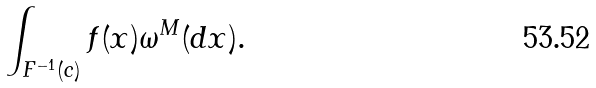Convert formula to latex. <formula><loc_0><loc_0><loc_500><loc_500>\int _ { F ^ { - 1 } ( c ) } f ( x ) \omega ^ { M } ( d x ) .</formula> 